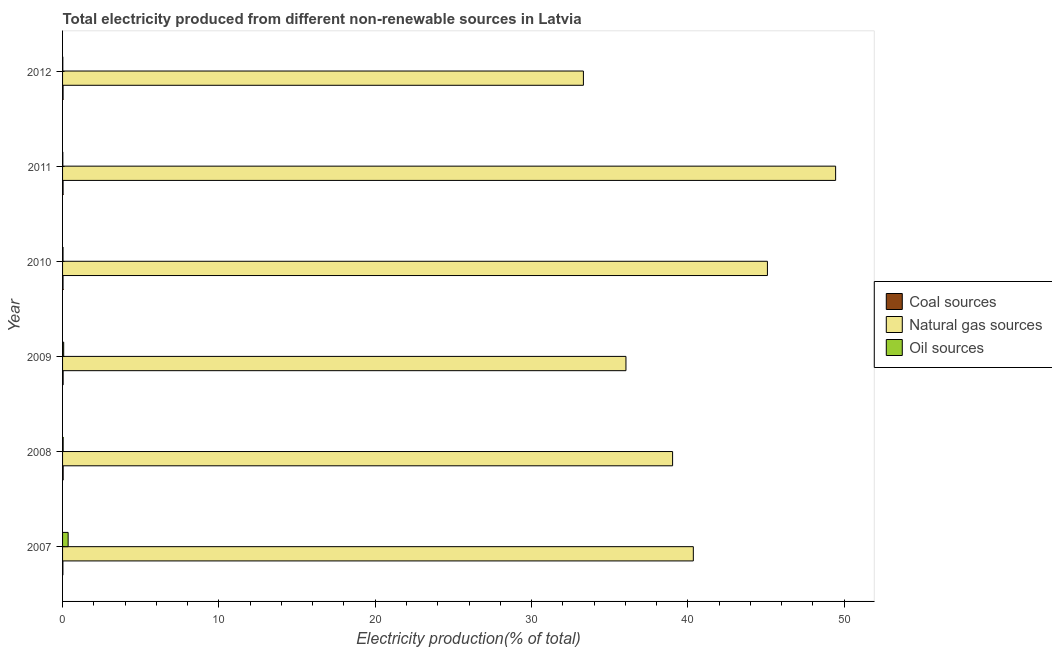How many different coloured bars are there?
Offer a very short reply. 3. How many groups of bars are there?
Offer a very short reply. 6. Are the number of bars on each tick of the Y-axis equal?
Your answer should be very brief. Yes. How many bars are there on the 3rd tick from the bottom?
Keep it short and to the point. 3. What is the percentage of electricity produced by natural gas in 2010?
Offer a terse response. 45.09. Across all years, what is the maximum percentage of electricity produced by natural gas?
Provide a succinct answer. 49.45. Across all years, what is the minimum percentage of electricity produced by oil sources?
Your answer should be very brief. 0.02. In which year was the percentage of electricity produced by coal maximum?
Provide a succinct answer. 2008. What is the total percentage of electricity produced by coal in the graph?
Offer a terse response. 0.19. What is the difference between the percentage of electricity produced by natural gas in 2009 and that in 2010?
Your response must be concise. -9.05. What is the difference between the percentage of electricity produced by oil sources in 2010 and the percentage of electricity produced by natural gas in 2011?
Provide a succinct answer. -49.42. What is the average percentage of electricity produced by natural gas per year?
Offer a very short reply. 40.54. In the year 2012, what is the difference between the percentage of electricity produced by natural gas and percentage of electricity produced by oil sources?
Your response must be concise. 33.3. In how many years, is the percentage of electricity produced by natural gas greater than 38 %?
Give a very brief answer. 4. What is the ratio of the percentage of electricity produced by oil sources in 2009 to that in 2012?
Ensure brevity in your answer.  4.43. What is the difference between the highest and the second highest percentage of electricity produced by natural gas?
Your answer should be compact. 4.36. What is the difference between the highest and the lowest percentage of electricity produced by natural gas?
Your response must be concise. 16.13. In how many years, is the percentage of electricity produced by natural gas greater than the average percentage of electricity produced by natural gas taken over all years?
Provide a succinct answer. 2. What does the 2nd bar from the top in 2007 represents?
Give a very brief answer. Natural gas sources. What does the 2nd bar from the bottom in 2012 represents?
Your response must be concise. Natural gas sources. Are all the bars in the graph horizontal?
Offer a very short reply. Yes. What is the difference between two consecutive major ticks on the X-axis?
Offer a terse response. 10. Are the values on the major ticks of X-axis written in scientific E-notation?
Your answer should be compact. No. Does the graph contain any zero values?
Your answer should be compact. No. Where does the legend appear in the graph?
Your answer should be very brief. Center right. How are the legend labels stacked?
Ensure brevity in your answer.  Vertical. What is the title of the graph?
Your answer should be compact. Total electricity produced from different non-renewable sources in Latvia. What is the label or title of the X-axis?
Make the answer very short. Electricity production(% of total). What is the label or title of the Y-axis?
Provide a succinct answer. Year. What is the Electricity production(% of total) of Coal sources in 2007?
Provide a succinct answer. 0.02. What is the Electricity production(% of total) in Natural gas sources in 2007?
Provide a succinct answer. 40.35. What is the Electricity production(% of total) of Oil sources in 2007?
Offer a very short reply. 0.36. What is the Electricity production(% of total) in Coal sources in 2008?
Keep it short and to the point. 0.04. What is the Electricity production(% of total) in Natural gas sources in 2008?
Offer a terse response. 39.02. What is the Electricity production(% of total) of Oil sources in 2008?
Give a very brief answer. 0.04. What is the Electricity production(% of total) in Coal sources in 2009?
Your response must be concise. 0.04. What is the Electricity production(% of total) in Natural gas sources in 2009?
Keep it short and to the point. 36.04. What is the Electricity production(% of total) in Oil sources in 2009?
Make the answer very short. 0.07. What is the Electricity production(% of total) of Coal sources in 2010?
Keep it short and to the point. 0.03. What is the Electricity production(% of total) in Natural gas sources in 2010?
Offer a very short reply. 45.09. What is the Electricity production(% of total) in Oil sources in 2010?
Ensure brevity in your answer.  0.03. What is the Electricity production(% of total) in Coal sources in 2011?
Your answer should be very brief. 0.03. What is the Electricity production(% of total) in Natural gas sources in 2011?
Your response must be concise. 49.45. What is the Electricity production(% of total) of Oil sources in 2011?
Offer a terse response. 0.02. What is the Electricity production(% of total) in Coal sources in 2012?
Make the answer very short. 0.03. What is the Electricity production(% of total) in Natural gas sources in 2012?
Provide a succinct answer. 33.32. What is the Electricity production(% of total) in Oil sources in 2012?
Give a very brief answer. 0.02. Across all years, what is the maximum Electricity production(% of total) in Coal sources?
Your response must be concise. 0.04. Across all years, what is the maximum Electricity production(% of total) of Natural gas sources?
Offer a terse response. 49.45. Across all years, what is the maximum Electricity production(% of total) in Oil sources?
Make the answer very short. 0.36. Across all years, what is the minimum Electricity production(% of total) in Coal sources?
Give a very brief answer. 0.02. Across all years, what is the minimum Electricity production(% of total) of Natural gas sources?
Your response must be concise. 33.32. Across all years, what is the minimum Electricity production(% of total) of Oil sources?
Offer a very short reply. 0.02. What is the total Electricity production(% of total) of Coal sources in the graph?
Offer a terse response. 0.19. What is the total Electricity production(% of total) of Natural gas sources in the graph?
Make the answer very short. 243.26. What is the total Electricity production(% of total) of Oil sources in the graph?
Offer a terse response. 0.53. What is the difference between the Electricity production(% of total) of Coal sources in 2007 and that in 2008?
Your answer should be very brief. -0.02. What is the difference between the Electricity production(% of total) of Natural gas sources in 2007 and that in 2008?
Ensure brevity in your answer.  1.33. What is the difference between the Electricity production(% of total) in Oil sources in 2007 and that in 2008?
Keep it short and to the point. 0.32. What is the difference between the Electricity production(% of total) in Coal sources in 2007 and that in 2009?
Provide a succinct answer. -0.01. What is the difference between the Electricity production(% of total) in Natural gas sources in 2007 and that in 2009?
Keep it short and to the point. 4.31. What is the difference between the Electricity production(% of total) in Oil sources in 2007 and that in 2009?
Offer a terse response. 0.28. What is the difference between the Electricity production(% of total) of Coal sources in 2007 and that in 2010?
Ensure brevity in your answer.  -0.01. What is the difference between the Electricity production(% of total) in Natural gas sources in 2007 and that in 2010?
Your answer should be compact. -4.74. What is the difference between the Electricity production(% of total) in Oil sources in 2007 and that in 2010?
Your answer should be very brief. 0.33. What is the difference between the Electricity production(% of total) of Coal sources in 2007 and that in 2011?
Offer a terse response. -0.01. What is the difference between the Electricity production(% of total) in Natural gas sources in 2007 and that in 2011?
Your answer should be very brief. -9.1. What is the difference between the Electricity production(% of total) in Oil sources in 2007 and that in 2011?
Give a very brief answer. 0.34. What is the difference between the Electricity production(% of total) of Coal sources in 2007 and that in 2012?
Keep it short and to the point. -0.01. What is the difference between the Electricity production(% of total) in Natural gas sources in 2007 and that in 2012?
Your answer should be compact. 7.03. What is the difference between the Electricity production(% of total) of Oil sources in 2007 and that in 2012?
Keep it short and to the point. 0.34. What is the difference between the Electricity production(% of total) in Coal sources in 2008 and that in 2009?
Your answer should be compact. 0. What is the difference between the Electricity production(% of total) in Natural gas sources in 2008 and that in 2009?
Provide a succinct answer. 2.98. What is the difference between the Electricity production(% of total) in Oil sources in 2008 and that in 2009?
Keep it short and to the point. -0.03. What is the difference between the Electricity production(% of total) in Coal sources in 2008 and that in 2010?
Provide a succinct answer. 0.01. What is the difference between the Electricity production(% of total) of Natural gas sources in 2008 and that in 2010?
Give a very brief answer. -6.07. What is the difference between the Electricity production(% of total) in Oil sources in 2008 and that in 2010?
Keep it short and to the point. 0.01. What is the difference between the Electricity production(% of total) in Coal sources in 2008 and that in 2011?
Offer a very short reply. 0.01. What is the difference between the Electricity production(% of total) of Natural gas sources in 2008 and that in 2011?
Offer a terse response. -10.43. What is the difference between the Electricity production(% of total) of Oil sources in 2008 and that in 2011?
Provide a short and direct response. 0.02. What is the difference between the Electricity production(% of total) of Coal sources in 2008 and that in 2012?
Offer a terse response. 0.01. What is the difference between the Electricity production(% of total) of Natural gas sources in 2008 and that in 2012?
Provide a succinct answer. 5.7. What is the difference between the Electricity production(% of total) of Oil sources in 2008 and that in 2012?
Ensure brevity in your answer.  0.02. What is the difference between the Electricity production(% of total) of Coal sources in 2009 and that in 2010?
Ensure brevity in your answer.  0.01. What is the difference between the Electricity production(% of total) in Natural gas sources in 2009 and that in 2010?
Make the answer very short. -9.05. What is the difference between the Electricity production(% of total) of Oil sources in 2009 and that in 2010?
Offer a terse response. 0.04. What is the difference between the Electricity production(% of total) in Coal sources in 2009 and that in 2011?
Give a very brief answer. 0. What is the difference between the Electricity production(% of total) of Natural gas sources in 2009 and that in 2011?
Offer a very short reply. -13.41. What is the difference between the Electricity production(% of total) of Oil sources in 2009 and that in 2011?
Your response must be concise. 0.06. What is the difference between the Electricity production(% of total) of Coal sources in 2009 and that in 2012?
Provide a short and direct response. 0. What is the difference between the Electricity production(% of total) in Natural gas sources in 2009 and that in 2012?
Give a very brief answer. 2.72. What is the difference between the Electricity production(% of total) in Oil sources in 2009 and that in 2012?
Provide a succinct answer. 0.06. What is the difference between the Electricity production(% of total) in Coal sources in 2010 and that in 2011?
Offer a very short reply. -0. What is the difference between the Electricity production(% of total) in Natural gas sources in 2010 and that in 2011?
Your response must be concise. -4.36. What is the difference between the Electricity production(% of total) of Oil sources in 2010 and that in 2011?
Offer a very short reply. 0.01. What is the difference between the Electricity production(% of total) in Coal sources in 2010 and that in 2012?
Ensure brevity in your answer.  -0. What is the difference between the Electricity production(% of total) in Natural gas sources in 2010 and that in 2012?
Make the answer very short. 11.77. What is the difference between the Electricity production(% of total) in Oil sources in 2010 and that in 2012?
Keep it short and to the point. 0.01. What is the difference between the Electricity production(% of total) of Coal sources in 2011 and that in 2012?
Provide a succinct answer. 0. What is the difference between the Electricity production(% of total) of Natural gas sources in 2011 and that in 2012?
Keep it short and to the point. 16.13. What is the difference between the Electricity production(% of total) in Coal sources in 2007 and the Electricity production(% of total) in Natural gas sources in 2008?
Give a very brief answer. -39. What is the difference between the Electricity production(% of total) of Coal sources in 2007 and the Electricity production(% of total) of Oil sources in 2008?
Your answer should be compact. -0.02. What is the difference between the Electricity production(% of total) in Natural gas sources in 2007 and the Electricity production(% of total) in Oil sources in 2008?
Provide a succinct answer. 40.31. What is the difference between the Electricity production(% of total) of Coal sources in 2007 and the Electricity production(% of total) of Natural gas sources in 2009?
Offer a terse response. -36.02. What is the difference between the Electricity production(% of total) of Coal sources in 2007 and the Electricity production(% of total) of Oil sources in 2009?
Offer a very short reply. -0.05. What is the difference between the Electricity production(% of total) in Natural gas sources in 2007 and the Electricity production(% of total) in Oil sources in 2009?
Your answer should be compact. 40.28. What is the difference between the Electricity production(% of total) in Coal sources in 2007 and the Electricity production(% of total) in Natural gas sources in 2010?
Your answer should be very brief. -45.07. What is the difference between the Electricity production(% of total) in Coal sources in 2007 and the Electricity production(% of total) in Oil sources in 2010?
Keep it short and to the point. -0.01. What is the difference between the Electricity production(% of total) in Natural gas sources in 2007 and the Electricity production(% of total) in Oil sources in 2010?
Offer a very short reply. 40.32. What is the difference between the Electricity production(% of total) in Coal sources in 2007 and the Electricity production(% of total) in Natural gas sources in 2011?
Provide a short and direct response. -49.43. What is the difference between the Electricity production(% of total) of Coal sources in 2007 and the Electricity production(% of total) of Oil sources in 2011?
Make the answer very short. 0. What is the difference between the Electricity production(% of total) in Natural gas sources in 2007 and the Electricity production(% of total) in Oil sources in 2011?
Provide a succinct answer. 40.33. What is the difference between the Electricity production(% of total) of Coal sources in 2007 and the Electricity production(% of total) of Natural gas sources in 2012?
Keep it short and to the point. -33.3. What is the difference between the Electricity production(% of total) in Coal sources in 2007 and the Electricity production(% of total) in Oil sources in 2012?
Offer a very short reply. 0. What is the difference between the Electricity production(% of total) in Natural gas sources in 2007 and the Electricity production(% of total) in Oil sources in 2012?
Offer a terse response. 40.33. What is the difference between the Electricity production(% of total) in Coal sources in 2008 and the Electricity production(% of total) in Natural gas sources in 2009?
Make the answer very short. -36. What is the difference between the Electricity production(% of total) of Coal sources in 2008 and the Electricity production(% of total) of Oil sources in 2009?
Your answer should be very brief. -0.03. What is the difference between the Electricity production(% of total) of Natural gas sources in 2008 and the Electricity production(% of total) of Oil sources in 2009?
Provide a short and direct response. 38.95. What is the difference between the Electricity production(% of total) of Coal sources in 2008 and the Electricity production(% of total) of Natural gas sources in 2010?
Ensure brevity in your answer.  -45.05. What is the difference between the Electricity production(% of total) in Coal sources in 2008 and the Electricity production(% of total) in Oil sources in 2010?
Give a very brief answer. 0.01. What is the difference between the Electricity production(% of total) of Natural gas sources in 2008 and the Electricity production(% of total) of Oil sources in 2010?
Give a very brief answer. 38.99. What is the difference between the Electricity production(% of total) in Coal sources in 2008 and the Electricity production(% of total) in Natural gas sources in 2011?
Your answer should be very brief. -49.41. What is the difference between the Electricity production(% of total) of Coal sources in 2008 and the Electricity production(% of total) of Oil sources in 2011?
Your answer should be compact. 0.02. What is the difference between the Electricity production(% of total) of Natural gas sources in 2008 and the Electricity production(% of total) of Oil sources in 2011?
Provide a short and direct response. 39.01. What is the difference between the Electricity production(% of total) of Coal sources in 2008 and the Electricity production(% of total) of Natural gas sources in 2012?
Your answer should be compact. -33.28. What is the difference between the Electricity production(% of total) in Coal sources in 2008 and the Electricity production(% of total) in Oil sources in 2012?
Ensure brevity in your answer.  0.02. What is the difference between the Electricity production(% of total) in Natural gas sources in 2008 and the Electricity production(% of total) in Oil sources in 2012?
Your response must be concise. 39.01. What is the difference between the Electricity production(% of total) of Coal sources in 2009 and the Electricity production(% of total) of Natural gas sources in 2010?
Offer a very short reply. -45.05. What is the difference between the Electricity production(% of total) in Coal sources in 2009 and the Electricity production(% of total) in Oil sources in 2010?
Provide a succinct answer. 0.01. What is the difference between the Electricity production(% of total) of Natural gas sources in 2009 and the Electricity production(% of total) of Oil sources in 2010?
Your answer should be compact. 36.01. What is the difference between the Electricity production(% of total) of Coal sources in 2009 and the Electricity production(% of total) of Natural gas sources in 2011?
Your response must be concise. -49.41. What is the difference between the Electricity production(% of total) of Coal sources in 2009 and the Electricity production(% of total) of Oil sources in 2011?
Give a very brief answer. 0.02. What is the difference between the Electricity production(% of total) in Natural gas sources in 2009 and the Electricity production(% of total) in Oil sources in 2011?
Provide a succinct answer. 36.02. What is the difference between the Electricity production(% of total) in Coal sources in 2009 and the Electricity production(% of total) in Natural gas sources in 2012?
Offer a terse response. -33.28. What is the difference between the Electricity production(% of total) of Coal sources in 2009 and the Electricity production(% of total) of Oil sources in 2012?
Ensure brevity in your answer.  0.02. What is the difference between the Electricity production(% of total) in Natural gas sources in 2009 and the Electricity production(% of total) in Oil sources in 2012?
Offer a terse response. 36.02. What is the difference between the Electricity production(% of total) in Coal sources in 2010 and the Electricity production(% of total) in Natural gas sources in 2011?
Provide a short and direct response. -49.42. What is the difference between the Electricity production(% of total) in Coal sources in 2010 and the Electricity production(% of total) in Oil sources in 2011?
Offer a terse response. 0.01. What is the difference between the Electricity production(% of total) of Natural gas sources in 2010 and the Electricity production(% of total) of Oil sources in 2011?
Provide a succinct answer. 45.07. What is the difference between the Electricity production(% of total) in Coal sources in 2010 and the Electricity production(% of total) in Natural gas sources in 2012?
Your answer should be very brief. -33.29. What is the difference between the Electricity production(% of total) of Coal sources in 2010 and the Electricity production(% of total) of Oil sources in 2012?
Your answer should be compact. 0.01. What is the difference between the Electricity production(% of total) of Natural gas sources in 2010 and the Electricity production(% of total) of Oil sources in 2012?
Keep it short and to the point. 45.07. What is the difference between the Electricity production(% of total) in Coal sources in 2011 and the Electricity production(% of total) in Natural gas sources in 2012?
Your answer should be compact. -33.28. What is the difference between the Electricity production(% of total) in Coal sources in 2011 and the Electricity production(% of total) in Oil sources in 2012?
Offer a terse response. 0.02. What is the difference between the Electricity production(% of total) in Natural gas sources in 2011 and the Electricity production(% of total) in Oil sources in 2012?
Keep it short and to the point. 49.43. What is the average Electricity production(% of total) in Coal sources per year?
Provide a succinct answer. 0.03. What is the average Electricity production(% of total) of Natural gas sources per year?
Give a very brief answer. 40.54. What is the average Electricity production(% of total) in Oil sources per year?
Offer a very short reply. 0.09. In the year 2007, what is the difference between the Electricity production(% of total) in Coal sources and Electricity production(% of total) in Natural gas sources?
Ensure brevity in your answer.  -40.33. In the year 2007, what is the difference between the Electricity production(% of total) in Coal sources and Electricity production(% of total) in Oil sources?
Provide a succinct answer. -0.34. In the year 2007, what is the difference between the Electricity production(% of total) in Natural gas sources and Electricity production(% of total) in Oil sources?
Offer a terse response. 39.99. In the year 2008, what is the difference between the Electricity production(% of total) of Coal sources and Electricity production(% of total) of Natural gas sources?
Give a very brief answer. -38.98. In the year 2008, what is the difference between the Electricity production(% of total) in Coal sources and Electricity production(% of total) in Oil sources?
Provide a short and direct response. 0. In the year 2008, what is the difference between the Electricity production(% of total) of Natural gas sources and Electricity production(% of total) of Oil sources?
Provide a succinct answer. 38.98. In the year 2009, what is the difference between the Electricity production(% of total) in Coal sources and Electricity production(% of total) in Natural gas sources?
Your answer should be very brief. -36. In the year 2009, what is the difference between the Electricity production(% of total) in Coal sources and Electricity production(% of total) in Oil sources?
Your response must be concise. -0.04. In the year 2009, what is the difference between the Electricity production(% of total) of Natural gas sources and Electricity production(% of total) of Oil sources?
Provide a succinct answer. 35.97. In the year 2010, what is the difference between the Electricity production(% of total) in Coal sources and Electricity production(% of total) in Natural gas sources?
Your answer should be compact. -45.06. In the year 2010, what is the difference between the Electricity production(% of total) of Coal sources and Electricity production(% of total) of Oil sources?
Provide a short and direct response. 0. In the year 2010, what is the difference between the Electricity production(% of total) of Natural gas sources and Electricity production(% of total) of Oil sources?
Give a very brief answer. 45.06. In the year 2011, what is the difference between the Electricity production(% of total) of Coal sources and Electricity production(% of total) of Natural gas sources?
Offer a terse response. -49.42. In the year 2011, what is the difference between the Electricity production(% of total) in Coal sources and Electricity production(% of total) in Oil sources?
Provide a short and direct response. 0.02. In the year 2011, what is the difference between the Electricity production(% of total) of Natural gas sources and Electricity production(% of total) of Oil sources?
Your response must be concise. 49.43. In the year 2012, what is the difference between the Electricity production(% of total) in Coal sources and Electricity production(% of total) in Natural gas sources?
Ensure brevity in your answer.  -33.28. In the year 2012, what is the difference between the Electricity production(% of total) of Coal sources and Electricity production(% of total) of Oil sources?
Make the answer very short. 0.02. In the year 2012, what is the difference between the Electricity production(% of total) in Natural gas sources and Electricity production(% of total) in Oil sources?
Ensure brevity in your answer.  33.3. What is the ratio of the Electricity production(% of total) in Coal sources in 2007 to that in 2008?
Your response must be concise. 0.55. What is the ratio of the Electricity production(% of total) in Natural gas sources in 2007 to that in 2008?
Provide a succinct answer. 1.03. What is the ratio of the Electricity production(% of total) in Oil sources in 2007 to that in 2008?
Offer a very short reply. 9.4. What is the ratio of the Electricity production(% of total) in Coal sources in 2007 to that in 2009?
Offer a very short reply. 0.58. What is the ratio of the Electricity production(% of total) of Natural gas sources in 2007 to that in 2009?
Provide a succinct answer. 1.12. What is the ratio of the Electricity production(% of total) of Oil sources in 2007 to that in 2009?
Keep it short and to the point. 4.96. What is the ratio of the Electricity production(% of total) in Coal sources in 2007 to that in 2010?
Your answer should be very brief. 0.69. What is the ratio of the Electricity production(% of total) in Natural gas sources in 2007 to that in 2010?
Your answer should be very brief. 0.89. What is the ratio of the Electricity production(% of total) in Oil sources in 2007 to that in 2010?
Your response must be concise. 11.81. What is the ratio of the Electricity production(% of total) of Coal sources in 2007 to that in 2011?
Offer a very short reply. 0.64. What is the ratio of the Electricity production(% of total) of Natural gas sources in 2007 to that in 2011?
Provide a short and direct response. 0.82. What is the ratio of the Electricity production(% of total) of Oil sources in 2007 to that in 2011?
Your response must be concise. 21.72. What is the ratio of the Electricity production(% of total) of Coal sources in 2007 to that in 2012?
Make the answer very short. 0.65. What is the ratio of the Electricity production(% of total) in Natural gas sources in 2007 to that in 2012?
Provide a short and direct response. 1.21. What is the ratio of the Electricity production(% of total) of Oil sources in 2007 to that in 2012?
Offer a very short reply. 21.98. What is the ratio of the Electricity production(% of total) in Coal sources in 2008 to that in 2009?
Make the answer very short. 1.06. What is the ratio of the Electricity production(% of total) of Natural gas sources in 2008 to that in 2009?
Offer a very short reply. 1.08. What is the ratio of the Electricity production(% of total) of Oil sources in 2008 to that in 2009?
Your answer should be very brief. 0.53. What is the ratio of the Electricity production(% of total) of Coal sources in 2008 to that in 2010?
Make the answer very short. 1.26. What is the ratio of the Electricity production(% of total) of Natural gas sources in 2008 to that in 2010?
Give a very brief answer. 0.87. What is the ratio of the Electricity production(% of total) in Oil sources in 2008 to that in 2010?
Provide a succinct answer. 1.26. What is the ratio of the Electricity production(% of total) of Coal sources in 2008 to that in 2011?
Your response must be concise. 1.16. What is the ratio of the Electricity production(% of total) in Natural gas sources in 2008 to that in 2011?
Offer a terse response. 0.79. What is the ratio of the Electricity production(% of total) of Oil sources in 2008 to that in 2011?
Make the answer very short. 2.31. What is the ratio of the Electricity production(% of total) of Coal sources in 2008 to that in 2012?
Provide a succinct answer. 1.17. What is the ratio of the Electricity production(% of total) of Natural gas sources in 2008 to that in 2012?
Provide a short and direct response. 1.17. What is the ratio of the Electricity production(% of total) of Oil sources in 2008 to that in 2012?
Ensure brevity in your answer.  2.34. What is the ratio of the Electricity production(% of total) in Coal sources in 2009 to that in 2010?
Provide a succinct answer. 1.19. What is the ratio of the Electricity production(% of total) of Natural gas sources in 2009 to that in 2010?
Provide a short and direct response. 0.8. What is the ratio of the Electricity production(% of total) of Oil sources in 2009 to that in 2010?
Make the answer very short. 2.38. What is the ratio of the Electricity production(% of total) of Coal sources in 2009 to that in 2011?
Your answer should be compact. 1.09. What is the ratio of the Electricity production(% of total) in Natural gas sources in 2009 to that in 2011?
Provide a short and direct response. 0.73. What is the ratio of the Electricity production(% of total) in Oil sources in 2009 to that in 2011?
Give a very brief answer. 4.38. What is the ratio of the Electricity production(% of total) in Coal sources in 2009 to that in 2012?
Your answer should be very brief. 1.11. What is the ratio of the Electricity production(% of total) of Natural gas sources in 2009 to that in 2012?
Offer a very short reply. 1.08. What is the ratio of the Electricity production(% of total) of Oil sources in 2009 to that in 2012?
Offer a very short reply. 4.43. What is the ratio of the Electricity production(% of total) in Coal sources in 2010 to that in 2011?
Your response must be concise. 0.92. What is the ratio of the Electricity production(% of total) in Natural gas sources in 2010 to that in 2011?
Provide a short and direct response. 0.91. What is the ratio of the Electricity production(% of total) in Oil sources in 2010 to that in 2011?
Your response must be concise. 1.84. What is the ratio of the Electricity production(% of total) of Coal sources in 2010 to that in 2012?
Give a very brief answer. 0.93. What is the ratio of the Electricity production(% of total) in Natural gas sources in 2010 to that in 2012?
Make the answer very short. 1.35. What is the ratio of the Electricity production(% of total) in Oil sources in 2010 to that in 2012?
Provide a succinct answer. 1.86. What is the ratio of the Electricity production(% of total) of Coal sources in 2011 to that in 2012?
Keep it short and to the point. 1.01. What is the ratio of the Electricity production(% of total) of Natural gas sources in 2011 to that in 2012?
Your answer should be compact. 1.48. What is the difference between the highest and the second highest Electricity production(% of total) of Coal sources?
Keep it short and to the point. 0. What is the difference between the highest and the second highest Electricity production(% of total) in Natural gas sources?
Provide a succinct answer. 4.36. What is the difference between the highest and the second highest Electricity production(% of total) in Oil sources?
Ensure brevity in your answer.  0.28. What is the difference between the highest and the lowest Electricity production(% of total) in Coal sources?
Give a very brief answer. 0.02. What is the difference between the highest and the lowest Electricity production(% of total) in Natural gas sources?
Provide a succinct answer. 16.13. What is the difference between the highest and the lowest Electricity production(% of total) of Oil sources?
Your response must be concise. 0.34. 